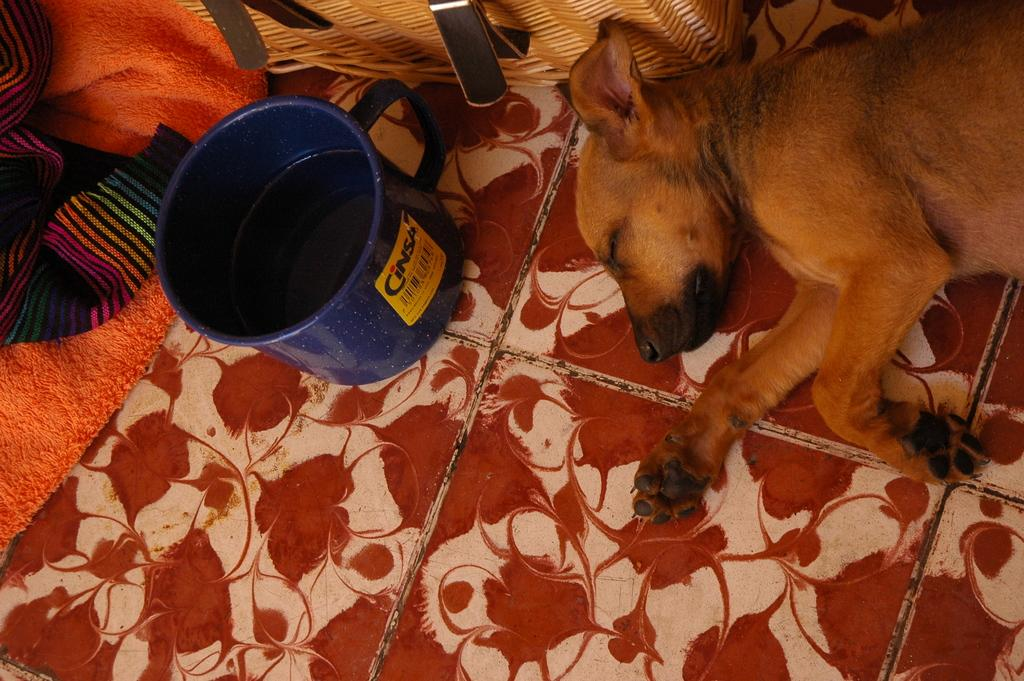What animal can be seen in the image? There is a dog in the image. What position is the dog in? The dog is lying on the floor. What else is near the dog? There are clothes beside the dog. What can be seen in the background of the image? There is water in a tub in the image. What type of linen is being used to cover the giraffe in the image? There is no giraffe or linen present in the image; it features a dog lying on the floor with clothes beside it and water in a tub in the background. 